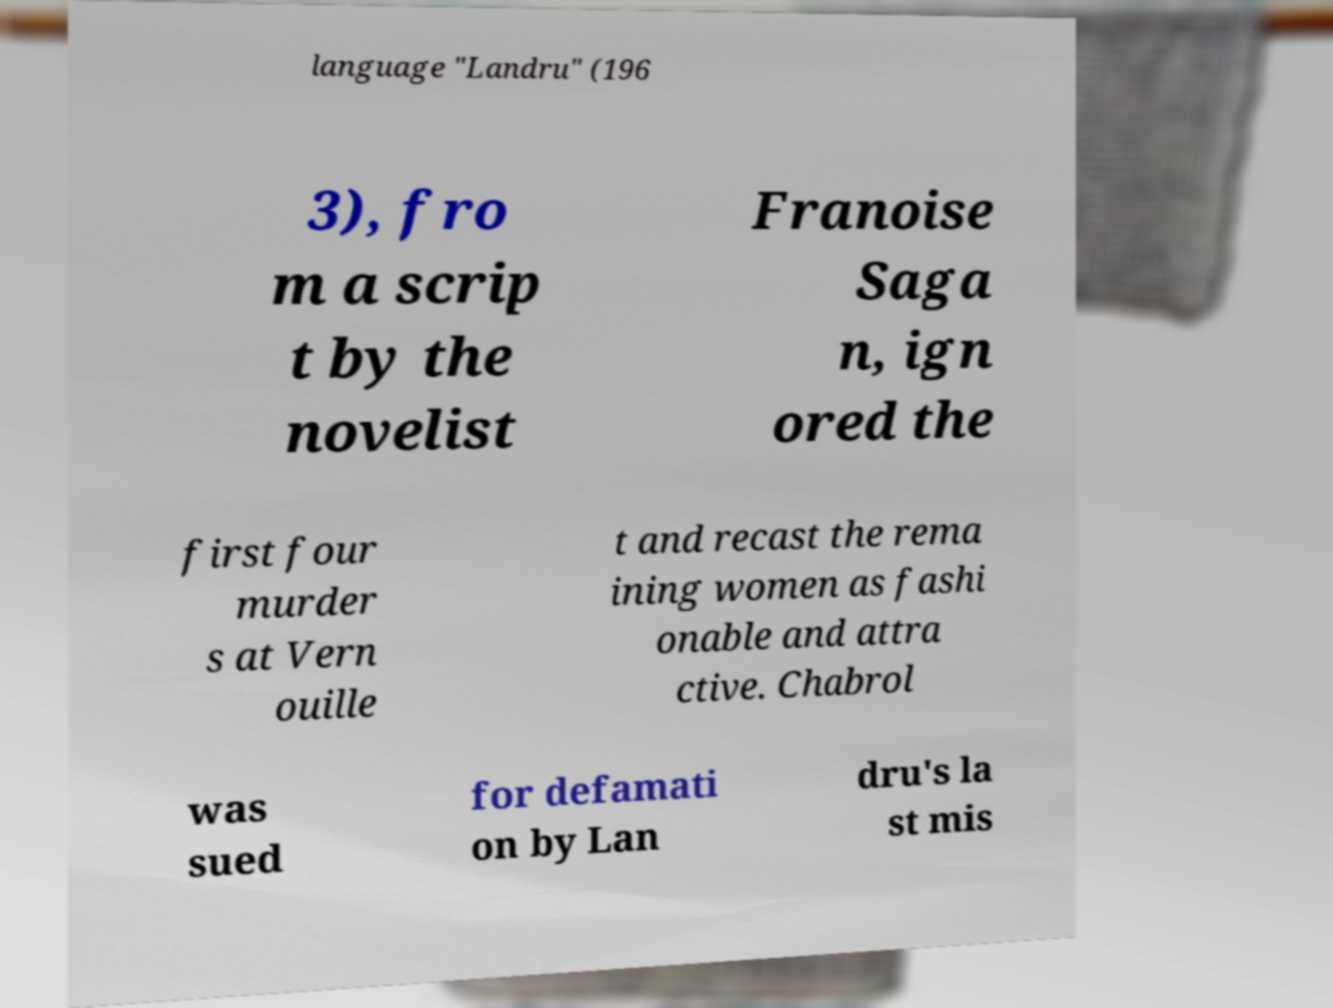Please read and relay the text visible in this image. What does it say? language "Landru" (196 3), fro m a scrip t by the novelist Franoise Saga n, ign ored the first four murder s at Vern ouille t and recast the rema ining women as fashi onable and attra ctive. Chabrol was sued for defamati on by Lan dru's la st mis 